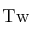<formula> <loc_0><loc_0><loc_500><loc_500>T w</formula> 